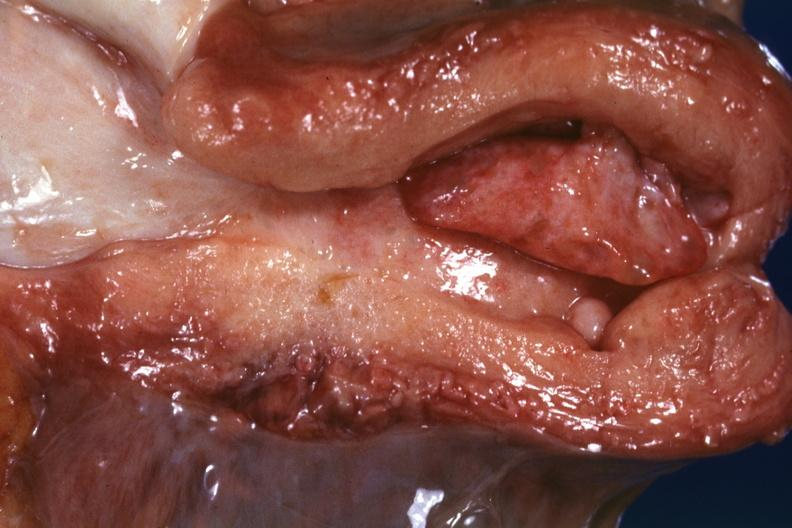what is present?
Answer the question using a single word or phrase. Uterus 